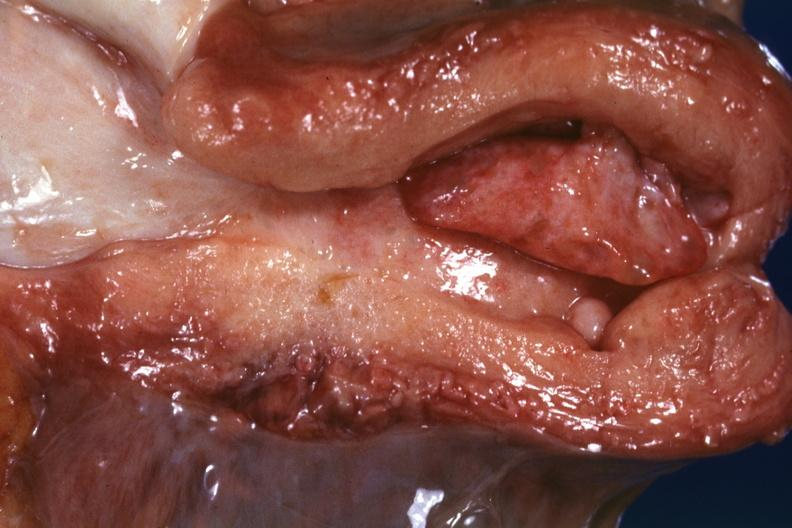what is present?
Answer the question using a single word or phrase. Uterus 